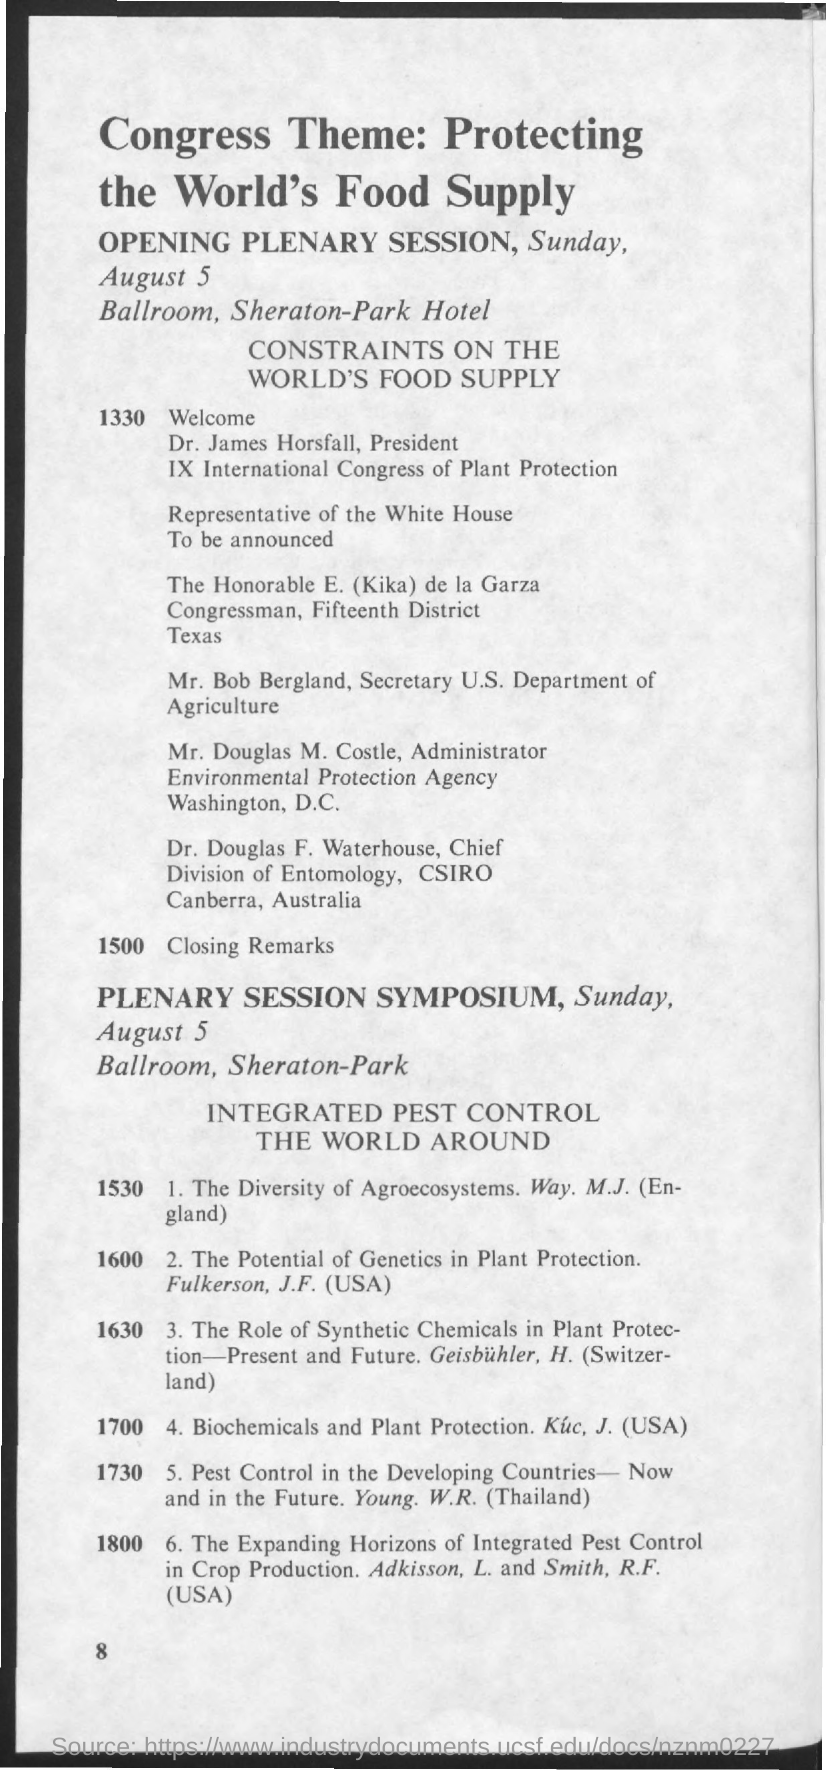Young.W.R is from which country?
Your answer should be very brief. Thailand. CSIRO is located in which country?
Make the answer very short. Australia. 